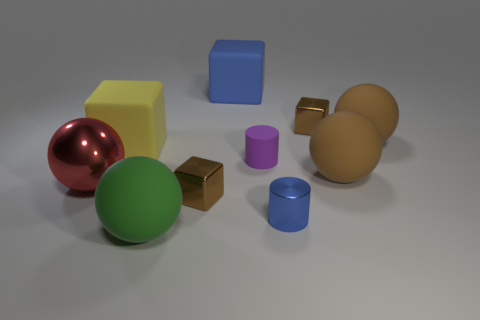How many other objects are there of the same color as the shiny cylinder?
Your response must be concise. 1. Is there any other thing that is made of the same material as the big green thing?
Your response must be concise. Yes. There is a metal object that is in front of the large red metallic thing and left of the matte cylinder; what color is it?
Give a very brief answer. Brown. There is a yellow object that is the same shape as the blue matte thing; what is its size?
Ensure brevity in your answer.  Large. How many metallic blocks have the same size as the red metallic ball?
Keep it short and to the point. 0. What material is the large green thing?
Offer a very short reply. Rubber. Are there any red objects in front of the small metallic cylinder?
Give a very brief answer. No. There is a purple thing that is the same material as the big blue cube; what is its size?
Give a very brief answer. Small. What number of matte cylinders have the same color as the big shiny object?
Your answer should be compact. 0. Are there fewer metal things that are on the left side of the red shiny ball than balls that are in front of the large green rubber object?
Keep it short and to the point. No. 